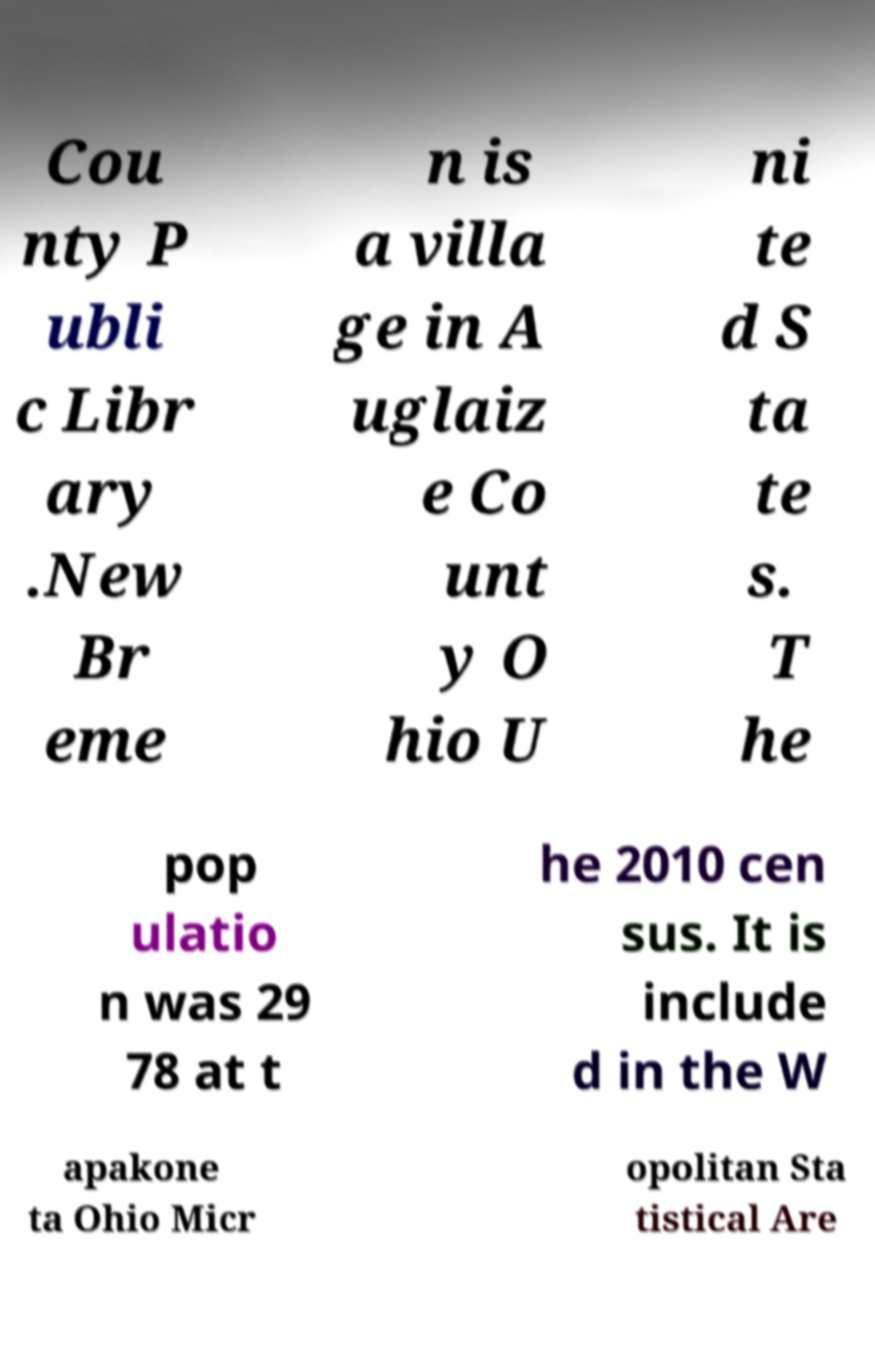There's text embedded in this image that I need extracted. Can you transcribe it verbatim? Cou nty P ubli c Libr ary .New Br eme n is a villa ge in A uglaiz e Co unt y O hio U ni te d S ta te s. T he pop ulatio n was 29 78 at t he 2010 cen sus. It is include d in the W apakone ta Ohio Micr opolitan Sta tistical Are 